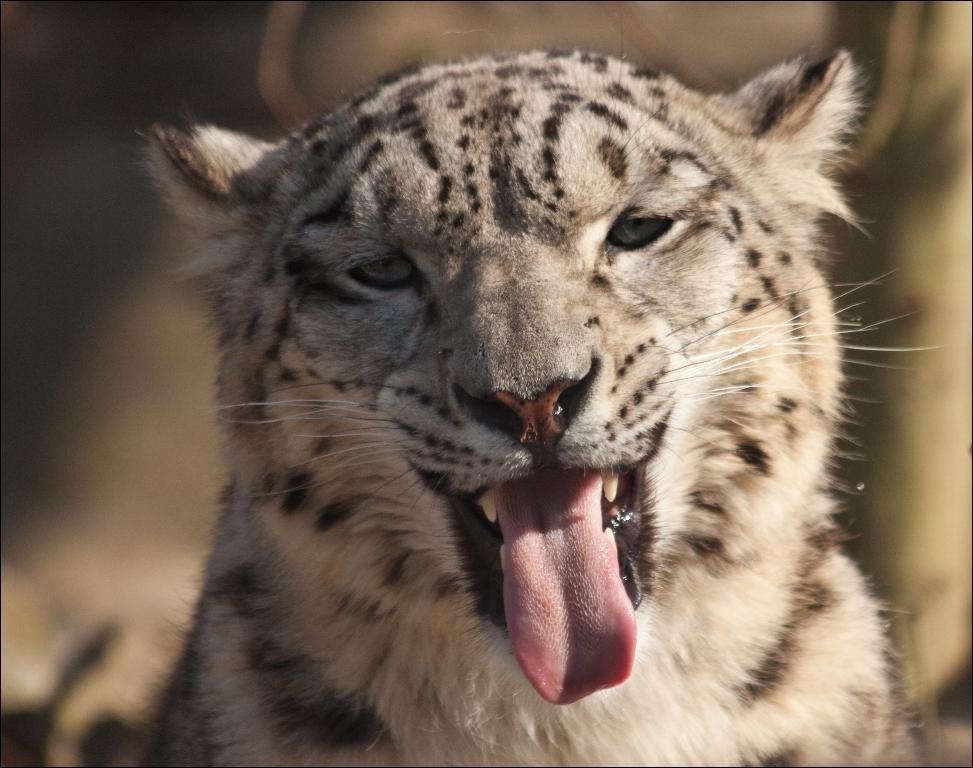What animal is the main subject of the image? There is a tiger in the image. Can you describe the background of the image? The background of the image is blurred. What type of watch is the tiger wearing in the image? There is no watch visible in the image, as the tiger is the main subject and there are no accessories mentioned in the facts. 